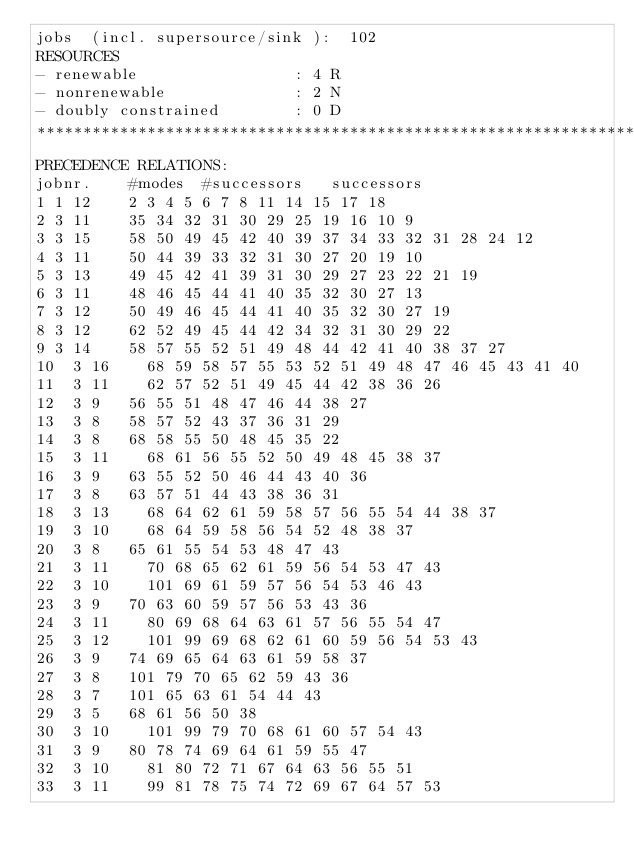<code> <loc_0><loc_0><loc_500><loc_500><_ObjectiveC_>jobs  (incl. supersource/sink ):	102
RESOURCES
- renewable                 : 4 R
- nonrenewable              : 2 N
- doubly constrained        : 0 D
************************************************************************
PRECEDENCE RELATIONS:
jobnr.    #modes  #successors   successors
1	1	12		2 3 4 5 6 7 8 11 14 15 17 18 
2	3	11		35 34 32 31 30 29 25 19 16 10 9 
3	3	15		58 50 49 45 42 40 39 37 34 33 32 31 28 24 12 
4	3	11		50 44 39 33 32 31 30 27 20 19 10 
5	3	13		49 45 42 41 39 31 30 29 27 23 22 21 19 
6	3	11		48 46 45 44 41 40 35 32 30 27 13 
7	3	12		50 49 46 45 44 41 40 35 32 30 27 19 
8	3	12		62 52 49 45 44 42 34 32 31 30 29 22 
9	3	14		58 57 55 52 51 49 48 44 42 41 40 38 37 27 
10	3	16		68 59 58 57 55 53 52 51 49 48 47 46 45 43 41 40 
11	3	11		62 57 52 51 49 45 44 42 38 36 26 
12	3	9		56 55 51 48 47 46 44 38 27 
13	3	8		58 57 52 43 37 36 31 29 
14	3	8		68 58 55 50 48 45 35 22 
15	3	11		68 61 56 55 52 50 49 48 45 38 37 
16	3	9		63 55 52 50 46 44 43 40 36 
17	3	8		63 57 51 44 43 38 36 31 
18	3	13		68 64 62 61 59 58 57 56 55 54 44 38 37 
19	3	10		68 64 59 58 56 54 52 48 38 37 
20	3	8		65 61 55 54 53 48 47 43 
21	3	11		70 68 65 62 61 59 56 54 53 47 43 
22	3	10		101 69 61 59 57 56 54 53 46 43 
23	3	9		70 63 60 59 57 56 53 43 36 
24	3	11		80 69 68 64 63 61 57 56 55 54 47 
25	3	12		101 99 69 68 62 61 60 59 56 54 53 43 
26	3	9		74 69 65 64 63 61 59 58 37 
27	3	8		101 79 70 65 62 59 43 36 
28	3	7		101 65 63 61 54 44 43 
29	3	5		68 61 56 50 38 
30	3	10		101 99 79 70 68 61 60 57 54 43 
31	3	9		80 78 74 69 64 61 59 55 47 
32	3	10		81 80 72 71 67 64 63 56 55 51 
33	3	11		99 81 78 75 74 72 69 67 64 57 53 </code> 